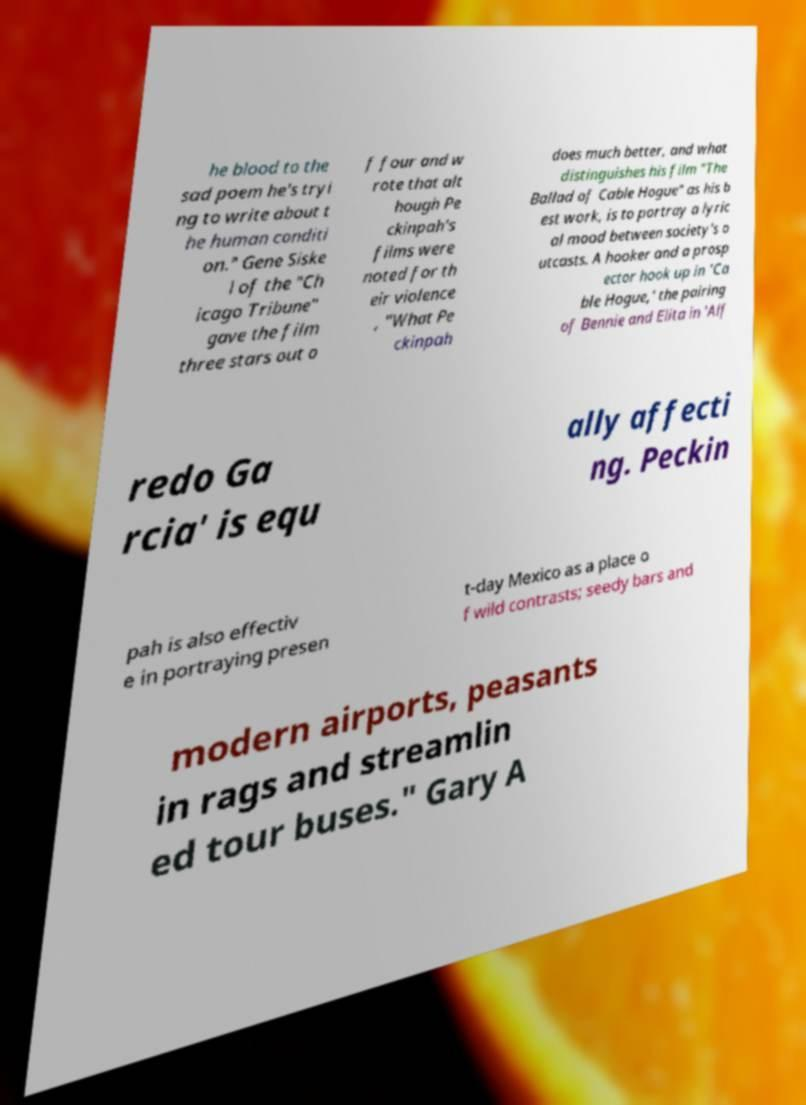Could you extract and type out the text from this image? he blood to the sad poem he's tryi ng to write about t he human conditi on." Gene Siske l of the "Ch icago Tribune" gave the film three stars out o f four and w rote that alt hough Pe ckinpah's films were noted for th eir violence , "What Pe ckinpah does much better, and what distinguishes his film "The Ballad of Cable Hogue" as his b est work, is to portray a lyric al mood between society's o utcasts. A hooker and a prosp ector hook up in 'Ca ble Hogue,' the pairing of Bennie and Elita in 'Alf redo Ga rcia' is equ ally affecti ng. Peckin pah is also effectiv e in portraying presen t-day Mexico as a place o f wild contrasts; seedy bars and modern airports, peasants in rags and streamlin ed tour buses." Gary A 